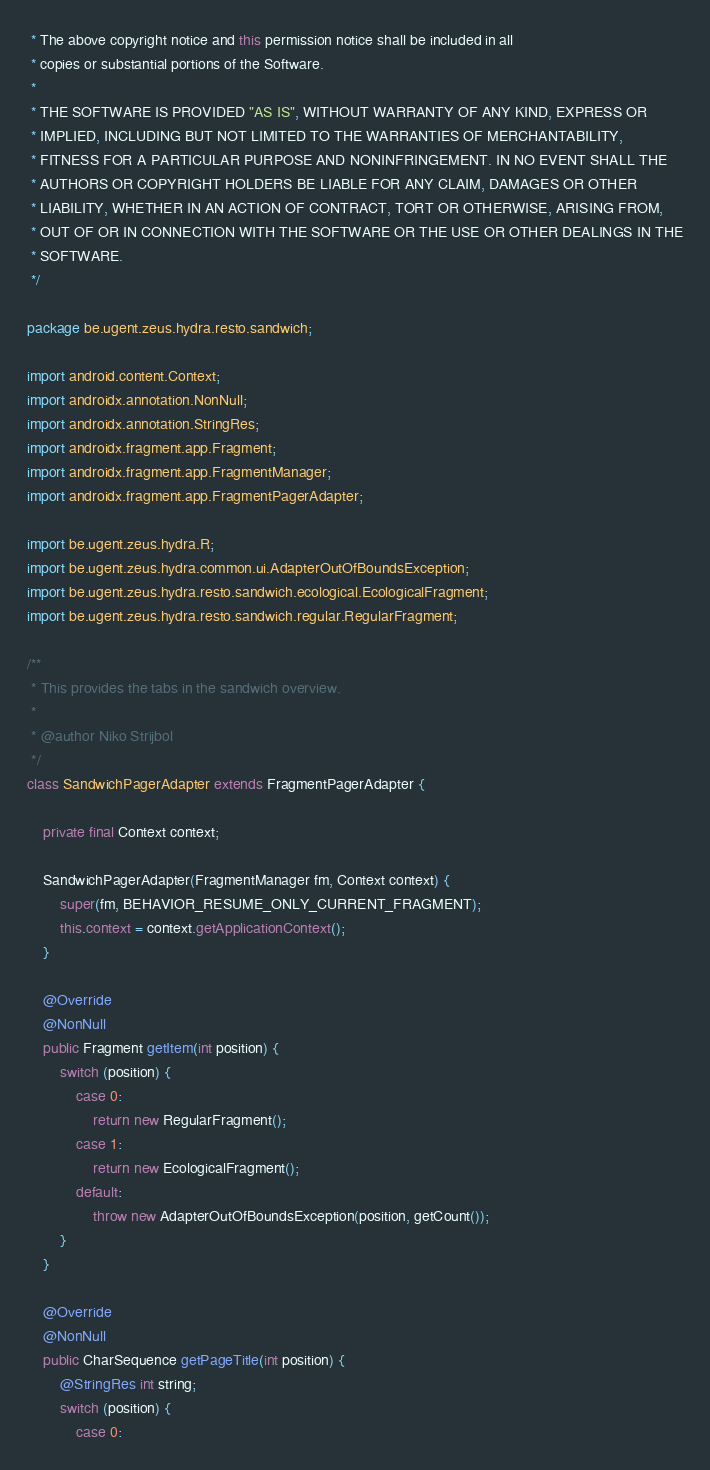<code> <loc_0><loc_0><loc_500><loc_500><_Java_> * The above copyright notice and this permission notice shall be included in all
 * copies or substantial portions of the Software.
 *
 * THE SOFTWARE IS PROVIDED "AS IS", WITHOUT WARRANTY OF ANY KIND, EXPRESS OR
 * IMPLIED, INCLUDING BUT NOT LIMITED TO THE WARRANTIES OF MERCHANTABILITY,
 * FITNESS FOR A PARTICULAR PURPOSE AND NONINFRINGEMENT. IN NO EVENT SHALL THE
 * AUTHORS OR COPYRIGHT HOLDERS BE LIABLE FOR ANY CLAIM, DAMAGES OR OTHER
 * LIABILITY, WHETHER IN AN ACTION OF CONTRACT, TORT OR OTHERWISE, ARISING FROM,
 * OUT OF OR IN CONNECTION WITH THE SOFTWARE OR THE USE OR OTHER DEALINGS IN THE
 * SOFTWARE.
 */

package be.ugent.zeus.hydra.resto.sandwich;

import android.content.Context;
import androidx.annotation.NonNull;
import androidx.annotation.StringRes;
import androidx.fragment.app.Fragment;
import androidx.fragment.app.FragmentManager;
import androidx.fragment.app.FragmentPagerAdapter;

import be.ugent.zeus.hydra.R;
import be.ugent.zeus.hydra.common.ui.AdapterOutOfBoundsException;
import be.ugent.zeus.hydra.resto.sandwich.ecological.EcologicalFragment;
import be.ugent.zeus.hydra.resto.sandwich.regular.RegularFragment;

/**
 * This provides the tabs in the sandwich overview.
 *
 * @author Niko Strijbol
 */
class SandwichPagerAdapter extends FragmentPagerAdapter {

    private final Context context;

    SandwichPagerAdapter(FragmentManager fm, Context context) {
        super(fm, BEHAVIOR_RESUME_ONLY_CURRENT_FRAGMENT);
        this.context = context.getApplicationContext();
    }

    @Override
    @NonNull
    public Fragment getItem(int position) {
        switch (position) {
            case 0:
                return new RegularFragment();
            case 1:
                return new EcologicalFragment();
            default:
                throw new AdapterOutOfBoundsException(position, getCount());
        }
    }

    @Override
    @NonNull
    public CharSequence getPageTitle(int position) {
        @StringRes int string;
        switch (position) {
            case 0:</code> 